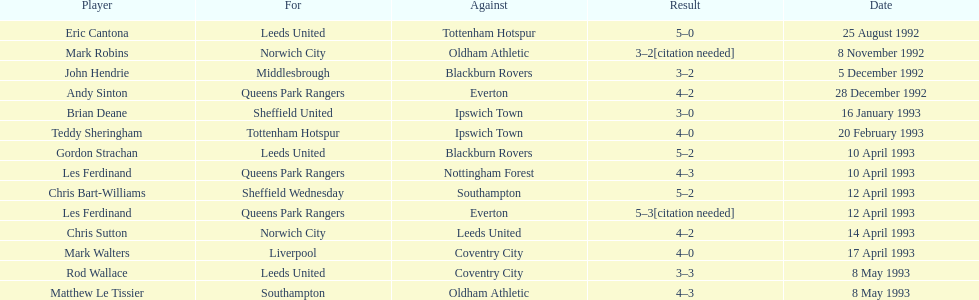Could you parse the entire table as a dict? {'header': ['Player', 'For', 'Against', 'Result', 'Date'], 'rows': [['Eric Cantona', 'Leeds United', 'Tottenham Hotspur', '5–0', '25 August 1992'], ['Mark Robins', 'Norwich City', 'Oldham Athletic', '3–2[citation needed]', '8 November 1992'], ['John Hendrie', 'Middlesbrough', 'Blackburn Rovers', '3–2', '5 December 1992'], ['Andy Sinton', 'Queens Park Rangers', 'Everton', '4–2', '28 December 1992'], ['Brian Deane', 'Sheffield United', 'Ipswich Town', '3–0', '16 January 1993'], ['Teddy Sheringham', 'Tottenham Hotspur', 'Ipswich Town', '4–0', '20 February 1993'], ['Gordon Strachan', 'Leeds United', 'Blackburn Rovers', '5–2', '10 April 1993'], ['Les Ferdinand', 'Queens Park Rangers', 'Nottingham Forest', '4–3', '10 April 1993'], ['Chris Bart-Williams', 'Sheffield Wednesday', 'Southampton', '5–2', '12 April 1993'], ['Les Ferdinand', 'Queens Park Rangers', 'Everton', '5–3[citation needed]', '12 April 1993'], ['Chris Sutton', 'Norwich City', 'Leeds United', '4–2', '14 April 1993'], ['Mark Walters', 'Liverpool', 'Coventry City', '4–0', '17 April 1993'], ['Rod Wallace', 'Leeds United', 'Coventry City', '3–3', '8 May 1993'], ['Matthew Le Tissier', 'Southampton', 'Oldham Athletic', '4–3', '8 May 1993']]} How many players were for leeds united? 3. 